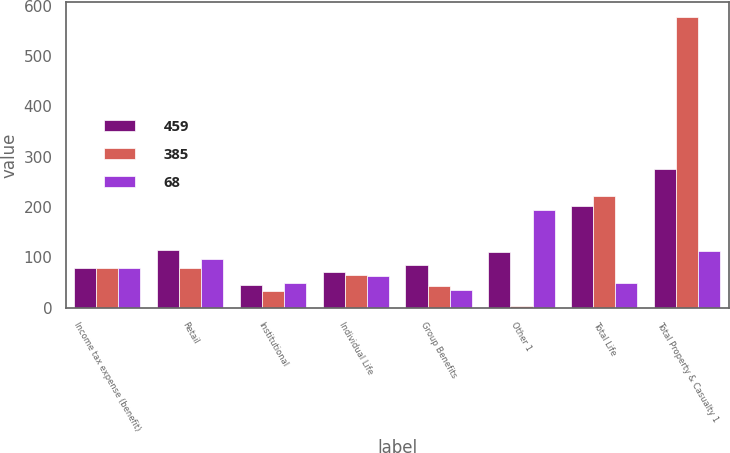Convert chart. <chart><loc_0><loc_0><loc_500><loc_500><stacked_bar_chart><ecel><fcel>Income tax expense (benefit)<fcel>Retail<fcel>Institutional<fcel>Individual Life<fcel>Group Benefits<fcel>Other 1<fcel>Total Life<fcel>Total Property & Casualty 1<nl><fcel>459<fcel>78<fcel>114<fcel>44<fcel>70<fcel>84<fcel>110<fcel>202<fcel>275<nl><fcel>385<fcel>78<fcel>78<fcel>32<fcel>64<fcel>43<fcel>4<fcel>221<fcel>578<nl><fcel>68<fcel>78<fcel>96<fcel>48<fcel>63<fcel>35<fcel>193<fcel>49<fcel>112<nl></chart> 